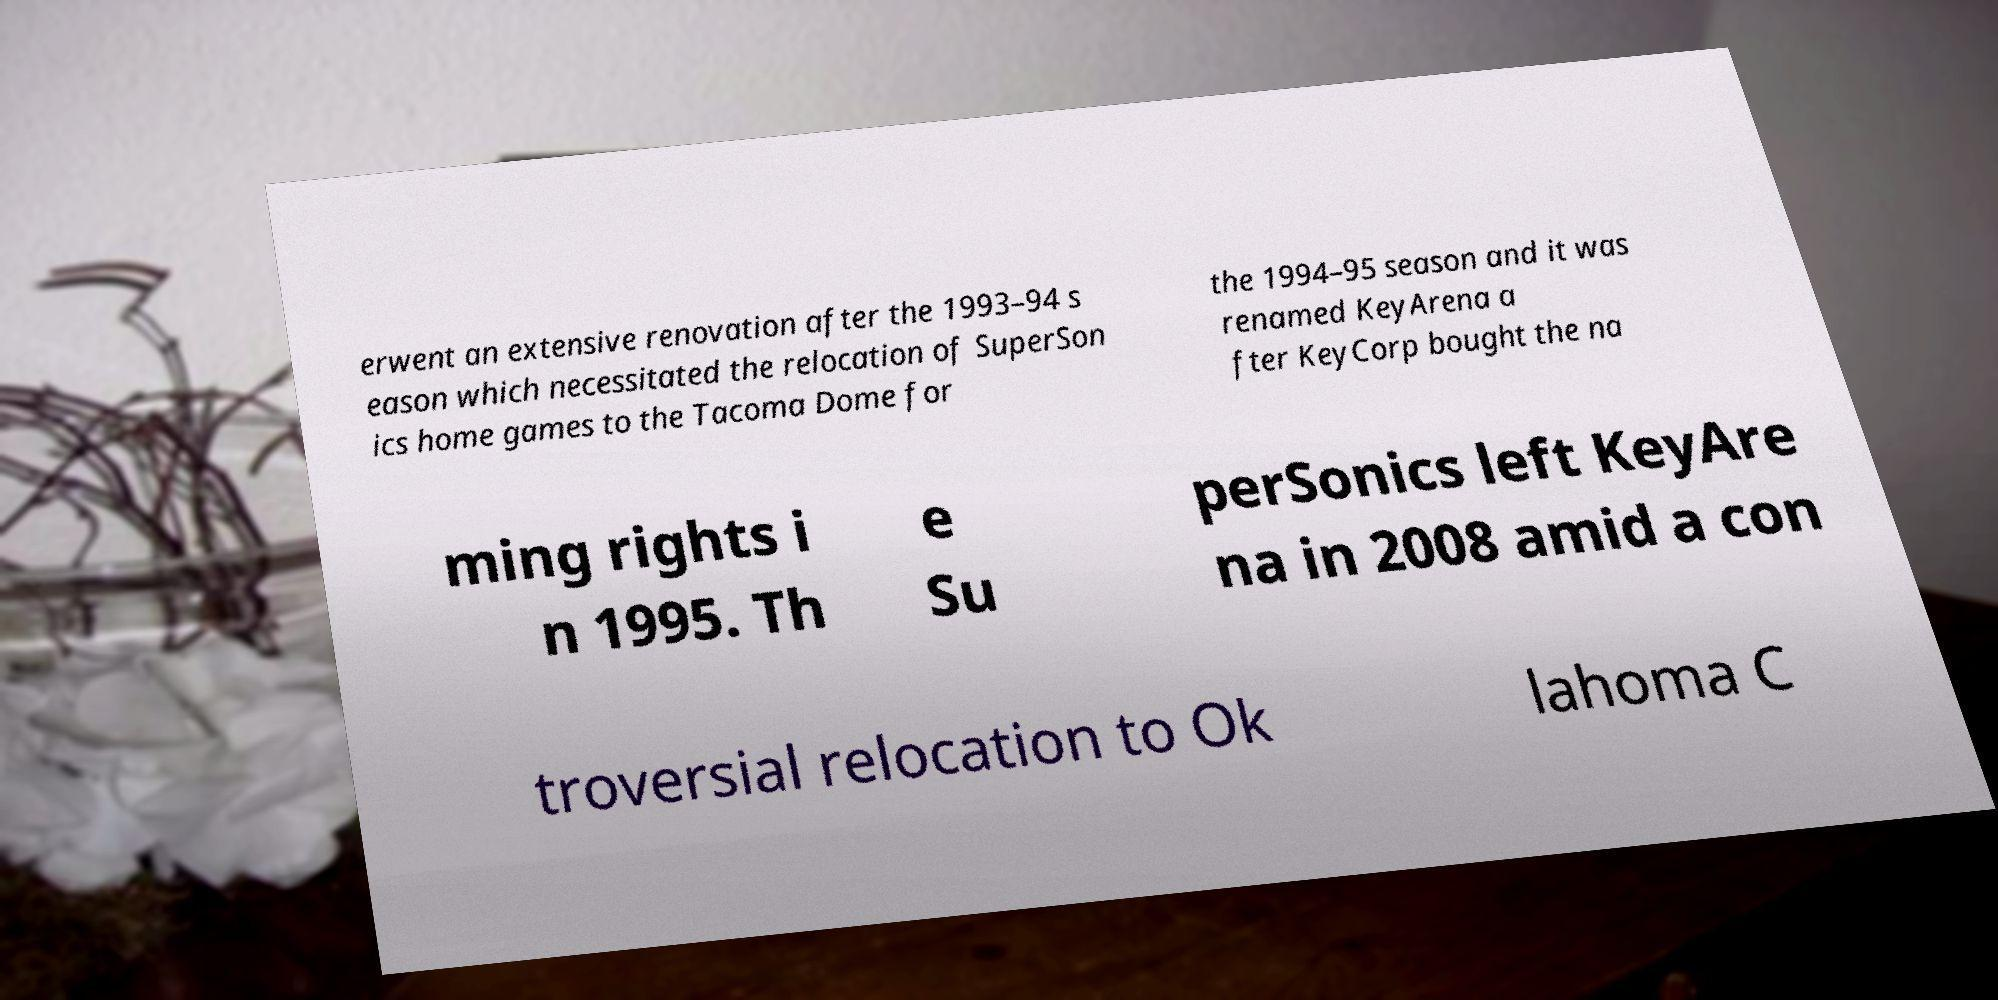Can you accurately transcribe the text from the provided image for me? erwent an extensive renovation after the 1993–94 s eason which necessitated the relocation of SuperSon ics home games to the Tacoma Dome for the 1994–95 season and it was renamed KeyArena a fter KeyCorp bought the na ming rights i n 1995. Th e Su perSonics left KeyAre na in 2008 amid a con troversial relocation to Ok lahoma C 